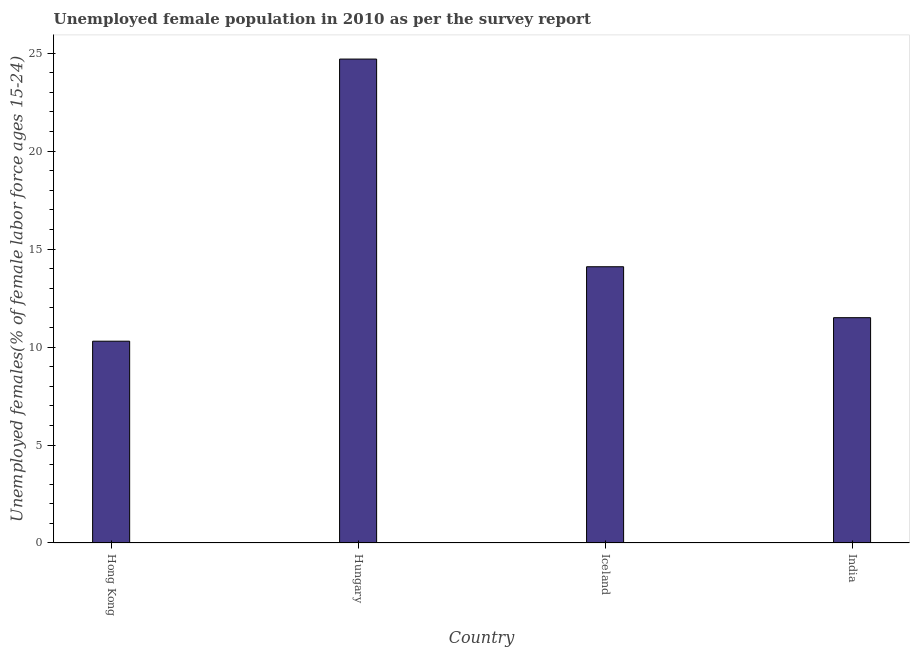Does the graph contain any zero values?
Make the answer very short. No. What is the title of the graph?
Your answer should be compact. Unemployed female population in 2010 as per the survey report. What is the label or title of the Y-axis?
Give a very brief answer. Unemployed females(% of female labor force ages 15-24). Across all countries, what is the maximum unemployed female youth?
Your answer should be very brief. 24.7. Across all countries, what is the minimum unemployed female youth?
Ensure brevity in your answer.  10.3. In which country was the unemployed female youth maximum?
Ensure brevity in your answer.  Hungary. In which country was the unemployed female youth minimum?
Provide a short and direct response. Hong Kong. What is the sum of the unemployed female youth?
Provide a succinct answer. 60.6. What is the difference between the unemployed female youth in Iceland and India?
Your answer should be compact. 2.6. What is the average unemployed female youth per country?
Provide a succinct answer. 15.15. What is the median unemployed female youth?
Offer a terse response. 12.8. What is the ratio of the unemployed female youth in Iceland to that in India?
Your answer should be very brief. 1.23. Is the unemployed female youth in Hungary less than that in India?
Ensure brevity in your answer.  No. Are all the bars in the graph horizontal?
Offer a terse response. No. Are the values on the major ticks of Y-axis written in scientific E-notation?
Your response must be concise. No. What is the Unemployed females(% of female labor force ages 15-24) of Hong Kong?
Make the answer very short. 10.3. What is the Unemployed females(% of female labor force ages 15-24) of Hungary?
Give a very brief answer. 24.7. What is the Unemployed females(% of female labor force ages 15-24) of Iceland?
Provide a short and direct response. 14.1. What is the Unemployed females(% of female labor force ages 15-24) in India?
Give a very brief answer. 11.5. What is the difference between the Unemployed females(% of female labor force ages 15-24) in Hong Kong and Hungary?
Offer a very short reply. -14.4. What is the difference between the Unemployed females(% of female labor force ages 15-24) in Hong Kong and Iceland?
Provide a short and direct response. -3.8. What is the difference between the Unemployed females(% of female labor force ages 15-24) in Hong Kong and India?
Keep it short and to the point. -1.2. What is the difference between the Unemployed females(% of female labor force ages 15-24) in Hungary and India?
Your answer should be very brief. 13.2. What is the ratio of the Unemployed females(% of female labor force ages 15-24) in Hong Kong to that in Hungary?
Ensure brevity in your answer.  0.42. What is the ratio of the Unemployed females(% of female labor force ages 15-24) in Hong Kong to that in Iceland?
Keep it short and to the point. 0.73. What is the ratio of the Unemployed females(% of female labor force ages 15-24) in Hong Kong to that in India?
Give a very brief answer. 0.9. What is the ratio of the Unemployed females(% of female labor force ages 15-24) in Hungary to that in Iceland?
Offer a very short reply. 1.75. What is the ratio of the Unemployed females(% of female labor force ages 15-24) in Hungary to that in India?
Offer a very short reply. 2.15. What is the ratio of the Unemployed females(% of female labor force ages 15-24) in Iceland to that in India?
Ensure brevity in your answer.  1.23. 